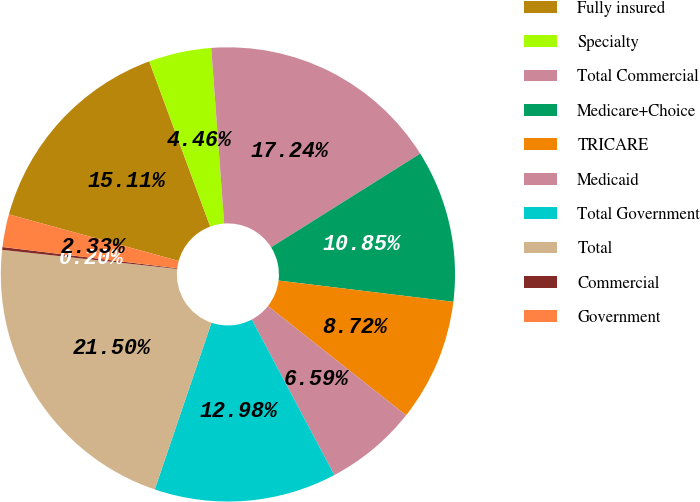Convert chart to OTSL. <chart><loc_0><loc_0><loc_500><loc_500><pie_chart><fcel>Fully insured<fcel>Specialty<fcel>Total Commercial<fcel>Medicare+Choice<fcel>TRICARE<fcel>Medicaid<fcel>Total Government<fcel>Total<fcel>Commercial<fcel>Government<nl><fcel>15.11%<fcel>4.46%<fcel>17.24%<fcel>10.85%<fcel>8.72%<fcel>6.59%<fcel>12.98%<fcel>21.5%<fcel>0.2%<fcel>2.33%<nl></chart> 